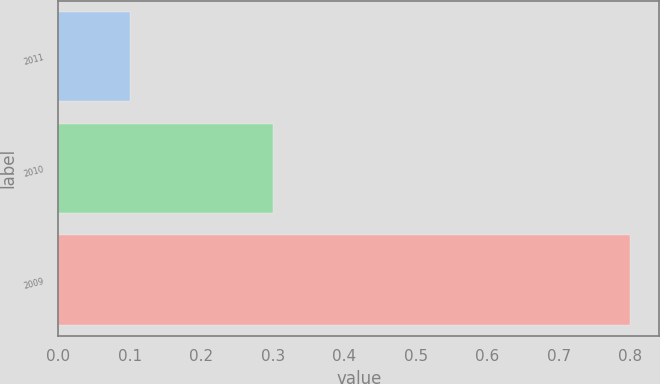<chart> <loc_0><loc_0><loc_500><loc_500><bar_chart><fcel>2011<fcel>2010<fcel>2009<nl><fcel>0.1<fcel>0.3<fcel>0.8<nl></chart> 